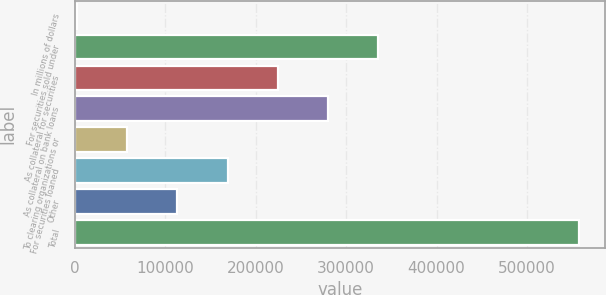<chart> <loc_0><loc_0><loc_500><loc_500><bar_chart><fcel>In millions of dollars<fcel>For securities sold under<fcel>As collateral for securities<fcel>As collateral on bank loans<fcel>To clearing organizations or<fcel>For securities loaned<fcel>Other<fcel>Total<nl><fcel>2009<fcel>335672<fcel>224451<fcel>280062<fcel>57619.5<fcel>168840<fcel>113230<fcel>558114<nl></chart> 